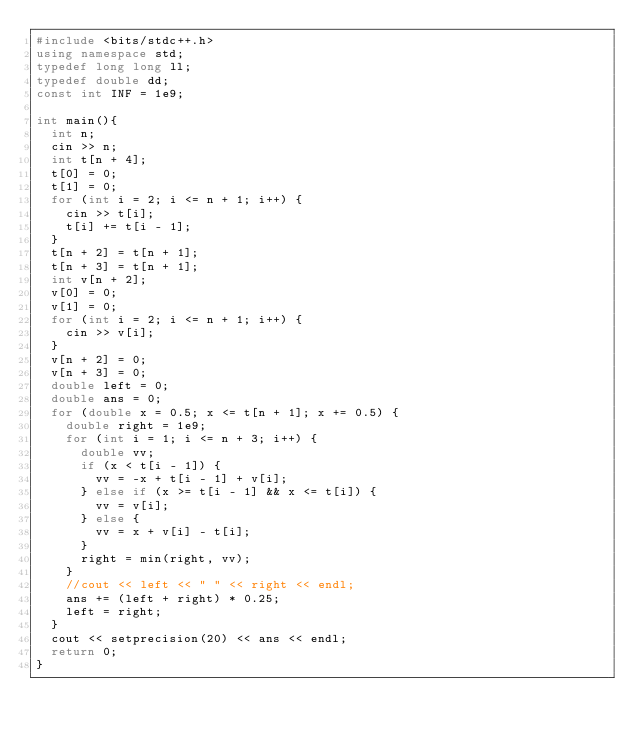<code> <loc_0><loc_0><loc_500><loc_500><_C++_>#include <bits/stdc++.h>
using namespace std;
typedef long long ll;
typedef double dd;
const int INF = 1e9;

int main(){
  int n;
  cin >> n;
  int t[n + 4];
  t[0] = 0;
  t[1] = 0;
  for (int i = 2; i <= n + 1; i++) {
    cin >> t[i];
    t[i] += t[i - 1];
  }
  t[n + 2] = t[n + 1];
  t[n + 3] = t[n + 1];
  int v[n + 2];
  v[0] = 0;
  v[1] = 0;
  for (int i = 2; i <= n + 1; i++) {
    cin >> v[i];
  }
  v[n + 2] = 0;
  v[n + 3] = 0;
  double left = 0;
  double ans = 0;
  for (double x = 0.5; x <= t[n + 1]; x += 0.5) {
    double right = 1e9;
    for (int i = 1; i <= n + 3; i++) {
      double vv;
      if (x < t[i - 1]) {
        vv = -x + t[i - 1] + v[i];
      } else if (x >= t[i - 1] && x <= t[i]) {
        vv = v[i];
      } else {
        vv = x + v[i] - t[i];
      }
      right = min(right, vv);
    }
    //cout << left << " " << right << endl;
    ans += (left + right) * 0.25;
    left = right;
  }
  cout << setprecision(20) << ans << endl;
  return 0;
}
</code> 